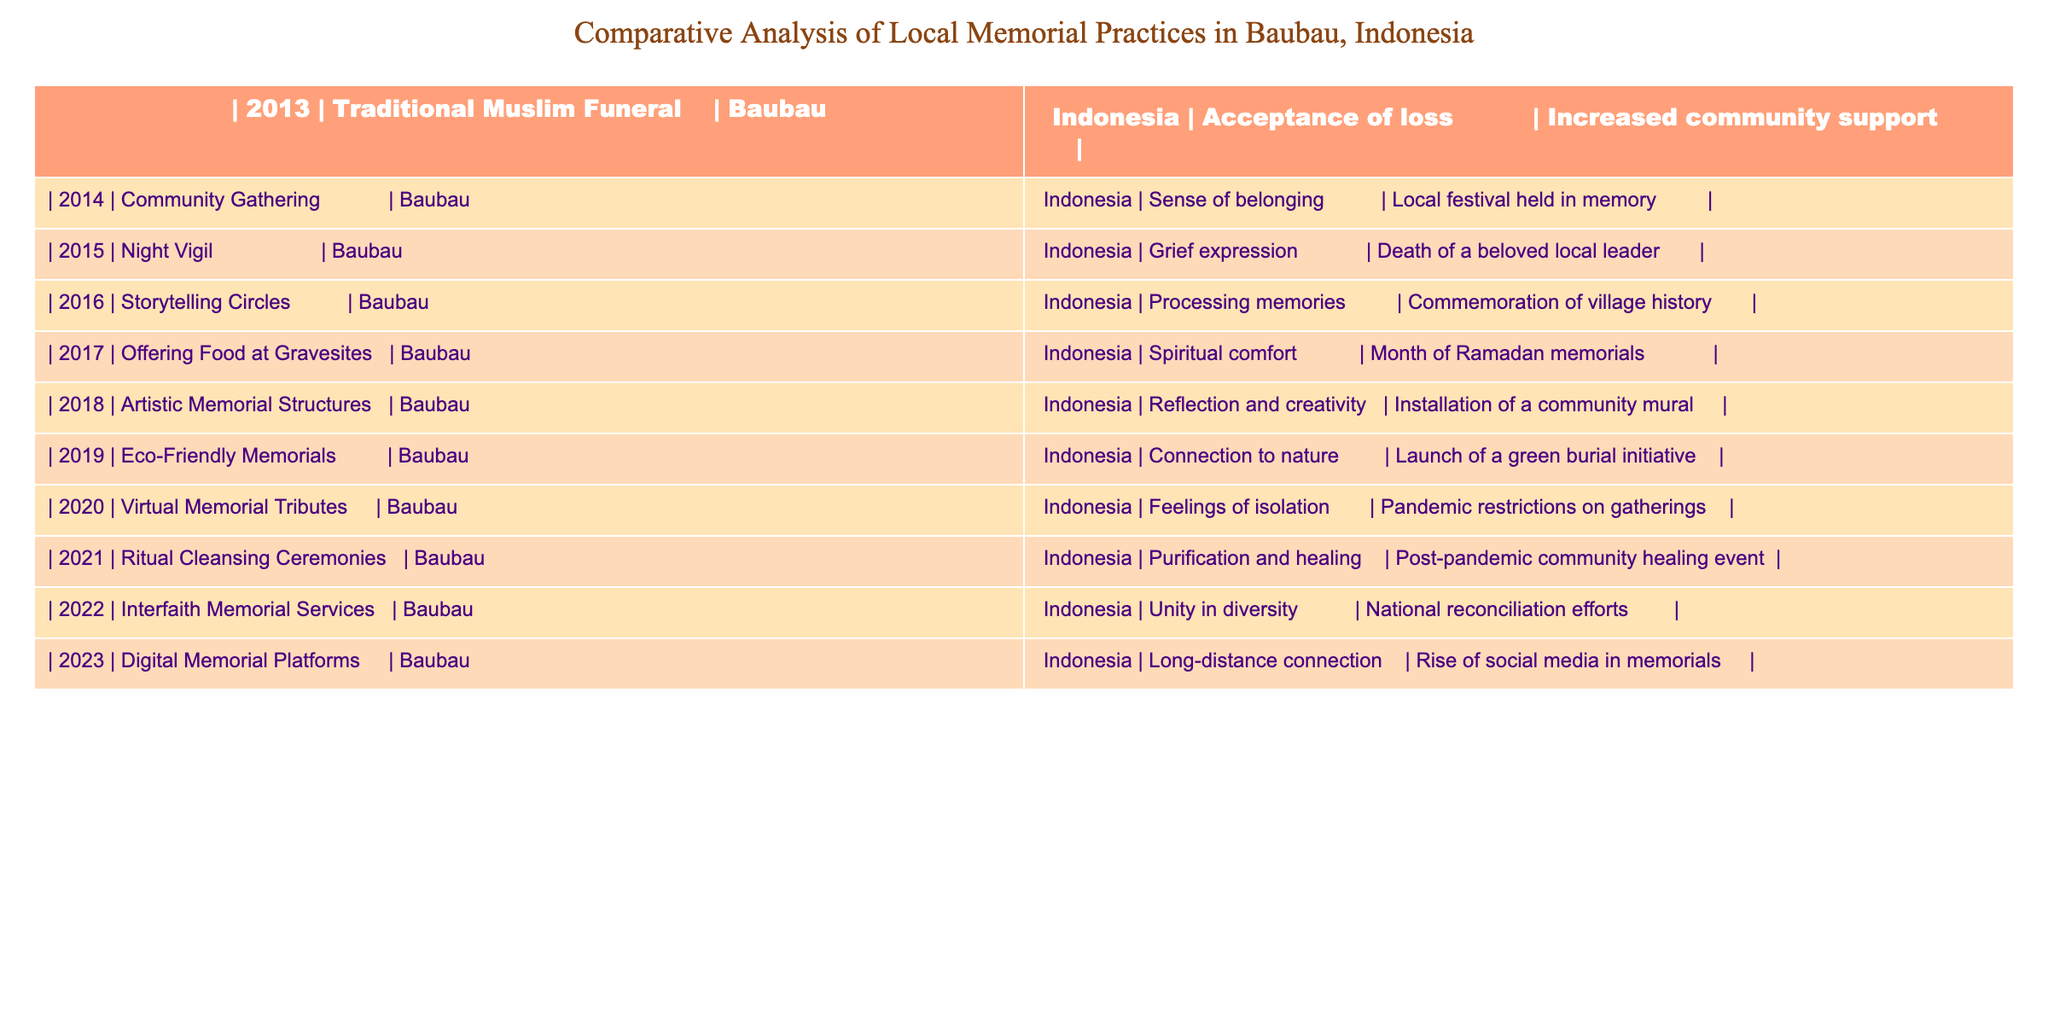What memorial practice was first recorded in the table? The first entry in the table corresponds to the year 2013, which indicates that the "Traditional Muslim Funeral" was the first memorial practice recorded.
Answer: Traditional Muslim Funeral How many memorial practices were recorded in the year 2020? The year 2020 has one entry listed in the table, which is "Virtual Memorial Tributes."
Answer: 1 Which memorial practice focused on "spiritual comfort"? The entry for the year 2017 describes "Offering Food at Gravesites" as focusing on "spiritual comfort."
Answer: Offering Food at Gravesites What are the two main psychological effects noted in 2018? In 2018, the table notes "Reflection and creativity" as the psychological effect associated with "Artistic Memorial Structures."
Answer: Reflection and creativity Which practice was implemented after the pandemic in 2021, and what was its primary psychological effect? The "Ritual Cleansing Ceremonies" were conducted in 2021, and their primary psychological effect was "Purification and healing."
Answer: Ritual Cleansing Ceremonies; Purification and healing How does the psychological effect of virtual memorials in 2020 contrast with that of traditional memorial practices prior? The psychological effect of virtual memorials in 2020 was "Feelings of isolation," contrasting with traditional practices focused more on community connection and support prior to 2020.
Answer: Feelings of isolation What was the most recent year listed in the table, and what type of memorial practice was noted? The most recent year listed is 2023, with "Digital Memorial Platforms" as the memorial practice noted.
Answer: 2023; Digital Memorial Platforms In what year did storytelling circles become a memorial practice, and what was the primary psychological effect associated with it? Storytelling circles became a memorial practice in 2016, with the primary psychological effect of "Processing memories."
Answer: 2016; Processing memories How do the psychological effects of community gatherings in 2014 compare with virtual memorials in 2020? Community gatherings in 2014 fostered a "Sense of belonging," whereas virtual memorials in 2020 led to "Feelings of isolation," showcasing a shift from community connection to isolation during the pandemic.
Answer: Sense of belonging vs. Feelings of isolation 